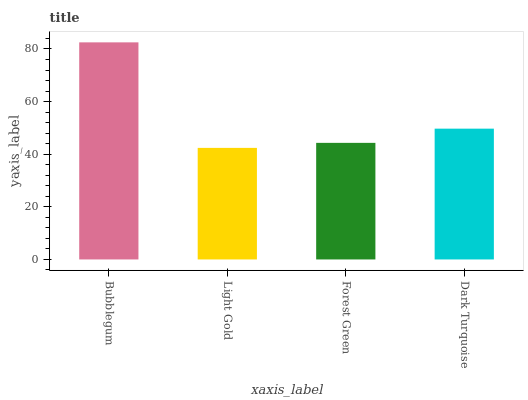Is Forest Green the minimum?
Answer yes or no. No. Is Forest Green the maximum?
Answer yes or no. No. Is Forest Green greater than Light Gold?
Answer yes or no. Yes. Is Light Gold less than Forest Green?
Answer yes or no. Yes. Is Light Gold greater than Forest Green?
Answer yes or no. No. Is Forest Green less than Light Gold?
Answer yes or no. No. Is Dark Turquoise the high median?
Answer yes or no. Yes. Is Forest Green the low median?
Answer yes or no. Yes. Is Bubblegum the high median?
Answer yes or no. No. Is Bubblegum the low median?
Answer yes or no. No. 